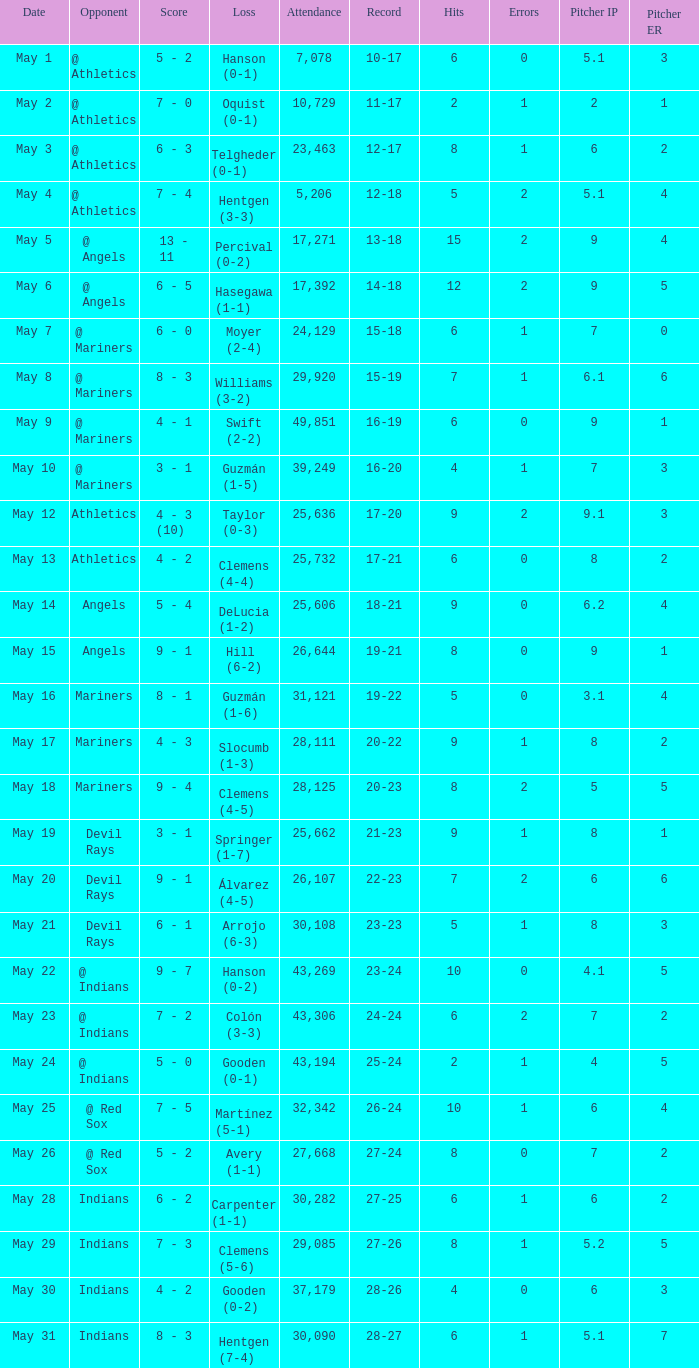When was the record 27-25? May 28. 